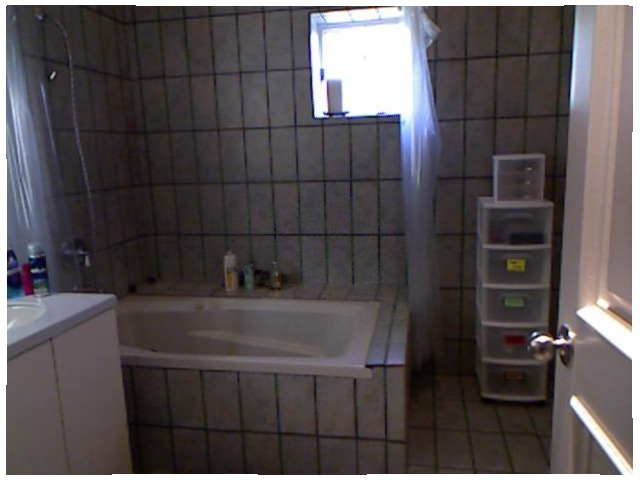<image>
Is the shampoo under the window? Yes. The shampoo is positioned underneath the window, with the window above it in the vertical space. Is the storage bins behind the door? No. The storage bins is not behind the door. From this viewpoint, the storage bins appears to be positioned elsewhere in the scene. Is the window above the tub? Yes. The window is positioned above the tub in the vertical space, higher up in the scene. 